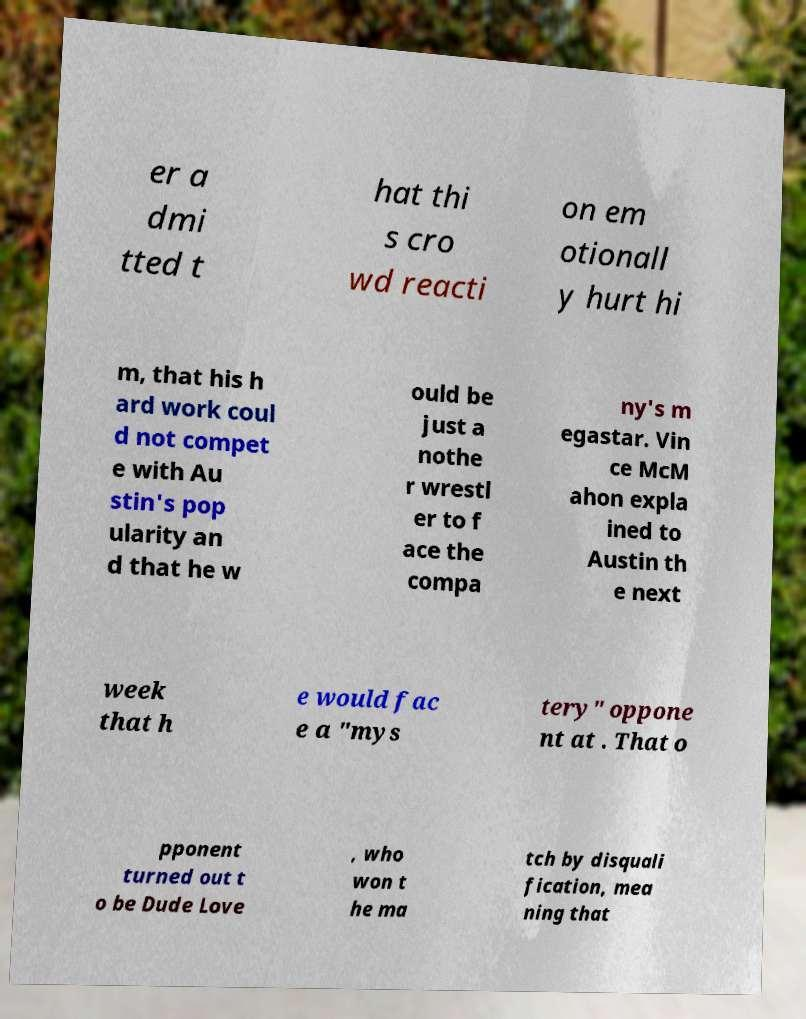Please read and relay the text visible in this image. What does it say? er a dmi tted t hat thi s cro wd reacti on em otionall y hurt hi m, that his h ard work coul d not compet e with Au stin's pop ularity an d that he w ould be just a nothe r wrestl er to f ace the compa ny's m egastar. Vin ce McM ahon expla ined to Austin th e next week that h e would fac e a "mys tery" oppone nt at . That o pponent turned out t o be Dude Love , who won t he ma tch by disquali fication, mea ning that 